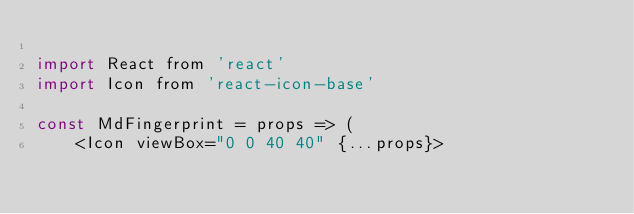Convert code to text. <code><loc_0><loc_0><loc_500><loc_500><_JavaScript_>
import React from 'react'
import Icon from 'react-icon-base'

const MdFingerprint = props => (
    <Icon viewBox="0 0 40 40" {...props}></code> 